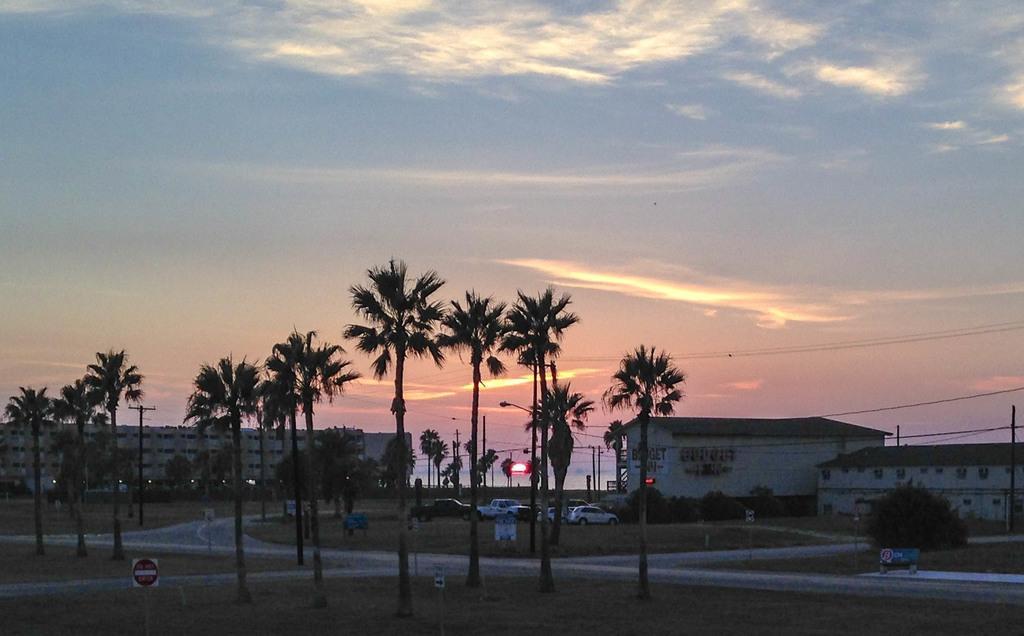Please provide a concise description of this image. This image consists of many trees. At the bottom, there is green grass on the ground. In the middle, there are roads. In the background, we can see the buildings and cars. At the top, there is sky. And we can see the sun in the sky. 